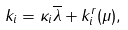<formula> <loc_0><loc_0><loc_500><loc_500>k _ { i } = \kappa _ { i } \overline { \lambda } + k _ { i } ^ { r } ( \mu ) ,</formula> 